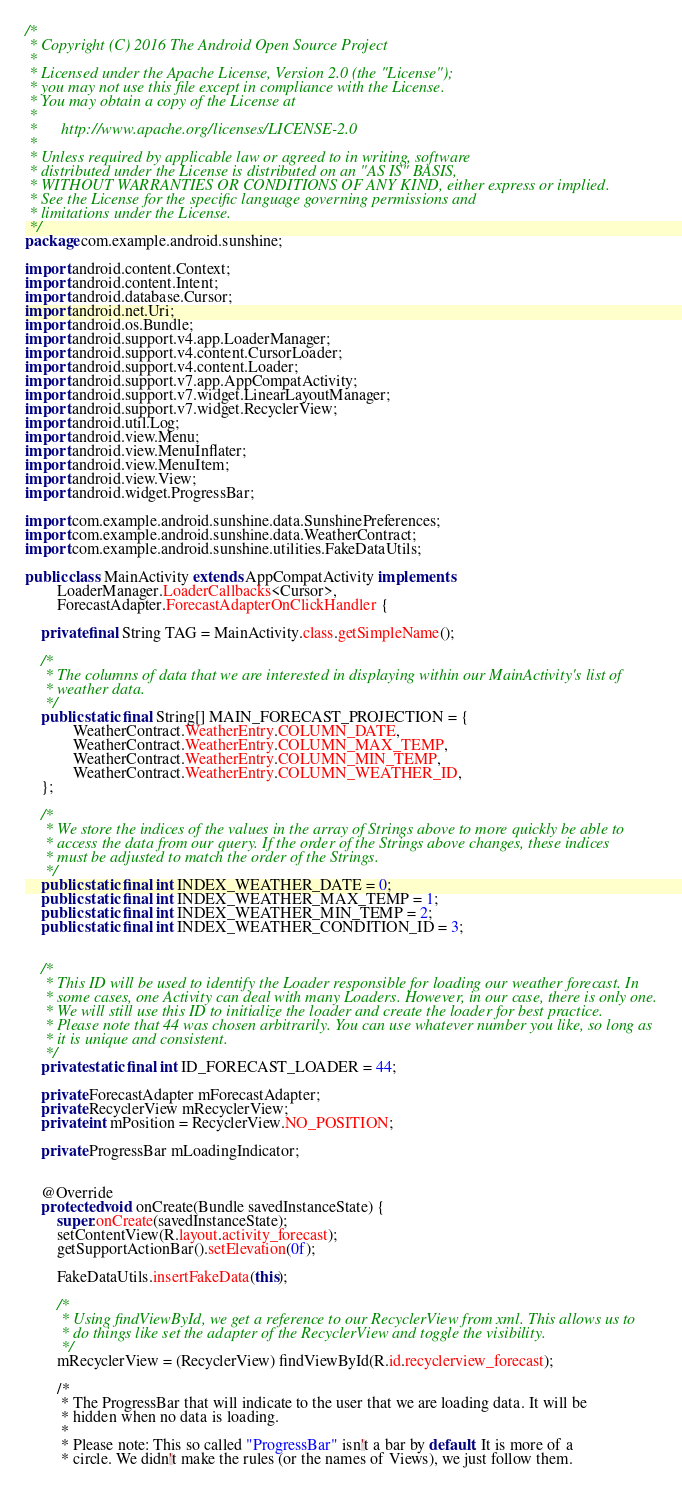<code> <loc_0><loc_0><loc_500><loc_500><_Java_>/*
 * Copyright (C) 2016 The Android Open Source Project
 *
 * Licensed under the Apache License, Version 2.0 (the "License");
 * you may not use this file except in compliance with the License.
 * You may obtain a copy of the License at
 *
 *      http://www.apache.org/licenses/LICENSE-2.0
 *
 * Unless required by applicable law or agreed to in writing, software
 * distributed under the License is distributed on an "AS IS" BASIS,
 * WITHOUT WARRANTIES OR CONDITIONS OF ANY KIND, either express or implied.
 * See the License for the specific language governing permissions and
 * limitations under the License.
 */
package com.example.android.sunshine;

import android.content.Context;
import android.content.Intent;
import android.database.Cursor;
import android.net.Uri;
import android.os.Bundle;
import android.support.v4.app.LoaderManager;
import android.support.v4.content.CursorLoader;
import android.support.v4.content.Loader;
import android.support.v7.app.AppCompatActivity;
import android.support.v7.widget.LinearLayoutManager;
import android.support.v7.widget.RecyclerView;
import android.util.Log;
import android.view.Menu;
import android.view.MenuInflater;
import android.view.MenuItem;
import android.view.View;
import android.widget.ProgressBar;

import com.example.android.sunshine.data.SunshinePreferences;
import com.example.android.sunshine.data.WeatherContract;
import com.example.android.sunshine.utilities.FakeDataUtils;

public class MainActivity extends AppCompatActivity implements
        LoaderManager.LoaderCallbacks<Cursor>,
        ForecastAdapter.ForecastAdapterOnClickHandler {

    private final String TAG = MainActivity.class.getSimpleName();

    /*
     * The columns of data that we are interested in displaying within our MainActivity's list of
     * weather data.
     */
    public static final String[] MAIN_FORECAST_PROJECTION = {
            WeatherContract.WeatherEntry.COLUMN_DATE,
            WeatherContract.WeatherEntry.COLUMN_MAX_TEMP,
            WeatherContract.WeatherEntry.COLUMN_MIN_TEMP,
            WeatherContract.WeatherEntry.COLUMN_WEATHER_ID,
    };

    /*
     * We store the indices of the values in the array of Strings above to more quickly be able to
     * access the data from our query. If the order of the Strings above changes, these indices
     * must be adjusted to match the order of the Strings.
     */
    public static final int INDEX_WEATHER_DATE = 0;
    public static final int INDEX_WEATHER_MAX_TEMP = 1;
    public static final int INDEX_WEATHER_MIN_TEMP = 2;
    public static final int INDEX_WEATHER_CONDITION_ID = 3;


    /*
     * This ID will be used to identify the Loader responsible for loading our weather forecast. In
     * some cases, one Activity can deal with many Loaders. However, in our case, there is only one.
     * We will still use this ID to initialize the loader and create the loader for best practice.
     * Please note that 44 was chosen arbitrarily. You can use whatever number you like, so long as
     * it is unique and consistent.
     */
    private static final int ID_FORECAST_LOADER = 44;

    private ForecastAdapter mForecastAdapter;
    private RecyclerView mRecyclerView;
    private int mPosition = RecyclerView.NO_POSITION;

    private ProgressBar mLoadingIndicator;


    @Override
    protected void onCreate(Bundle savedInstanceState) {
        super.onCreate(savedInstanceState);
        setContentView(R.layout.activity_forecast);
        getSupportActionBar().setElevation(0f);

        FakeDataUtils.insertFakeData(this);

        /*
         * Using findViewById, we get a reference to our RecyclerView from xml. This allows us to
         * do things like set the adapter of the RecyclerView and toggle the visibility.
         */
        mRecyclerView = (RecyclerView) findViewById(R.id.recyclerview_forecast);

        /*
         * The ProgressBar that will indicate to the user that we are loading data. It will be
         * hidden when no data is loading.
         *
         * Please note: This so called "ProgressBar" isn't a bar by default. It is more of a
         * circle. We didn't make the rules (or the names of Views), we just follow them.</code> 